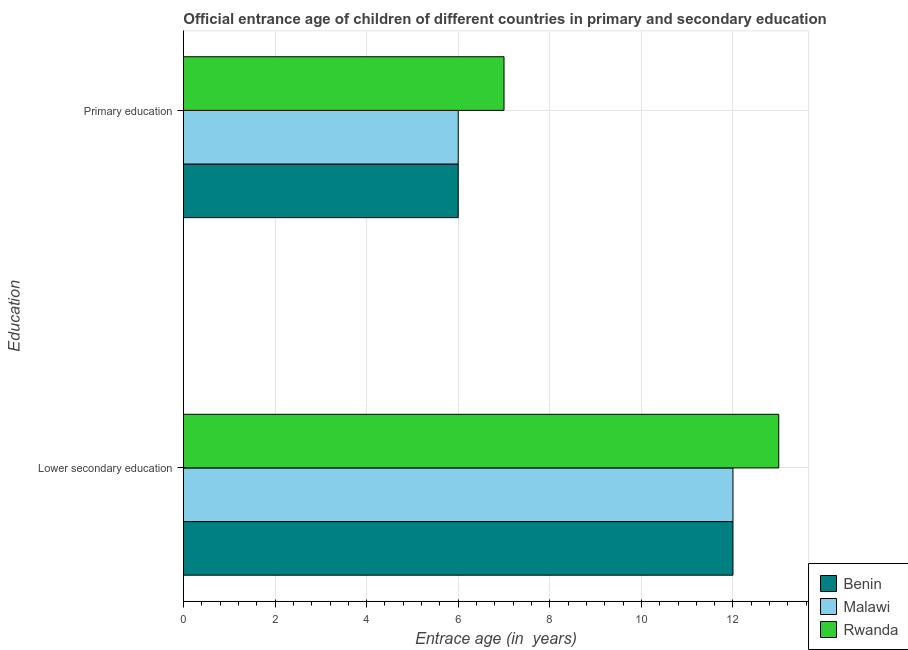How many different coloured bars are there?
Your answer should be compact. 3. How many groups of bars are there?
Your answer should be very brief. 2. Are the number of bars on each tick of the Y-axis equal?
Provide a succinct answer. Yes. What is the label of the 2nd group of bars from the top?
Provide a succinct answer. Lower secondary education. Across all countries, what is the maximum entrance age of children in lower secondary education?
Provide a short and direct response. 13. Across all countries, what is the minimum entrance age of children in lower secondary education?
Keep it short and to the point. 12. In which country was the entrance age of children in lower secondary education maximum?
Provide a succinct answer. Rwanda. In which country was the entrance age of chiildren in primary education minimum?
Ensure brevity in your answer.  Benin. What is the total entrance age of chiildren in primary education in the graph?
Provide a succinct answer. 19. What is the difference between the entrance age of children in lower secondary education in Rwanda and that in Benin?
Provide a short and direct response. 1. What is the difference between the entrance age of chiildren in primary education in Malawi and the entrance age of children in lower secondary education in Benin?
Provide a short and direct response. -6. What is the average entrance age of chiildren in primary education per country?
Offer a very short reply. 6.33. In how many countries, is the entrance age of chiildren in primary education greater than 4.8 years?
Keep it short and to the point. 3. What is the ratio of the entrance age of chiildren in primary education in Malawi to that in Rwanda?
Make the answer very short. 0.86. What does the 3rd bar from the top in Primary education represents?
Offer a terse response. Benin. What does the 2nd bar from the bottom in Primary education represents?
Your answer should be compact. Malawi. Are all the bars in the graph horizontal?
Your answer should be compact. Yes. How many countries are there in the graph?
Give a very brief answer. 3. Does the graph contain any zero values?
Ensure brevity in your answer.  No. How many legend labels are there?
Provide a succinct answer. 3. How are the legend labels stacked?
Provide a short and direct response. Vertical. What is the title of the graph?
Ensure brevity in your answer.  Official entrance age of children of different countries in primary and secondary education. Does "Brazil" appear as one of the legend labels in the graph?
Your answer should be very brief. No. What is the label or title of the X-axis?
Provide a succinct answer. Entrace age (in  years). What is the label or title of the Y-axis?
Make the answer very short. Education. What is the Entrace age (in  years) in Rwanda in Lower secondary education?
Give a very brief answer. 13. What is the Entrace age (in  years) of Benin in Primary education?
Your answer should be very brief. 6. What is the Entrace age (in  years) in Rwanda in Primary education?
Your response must be concise. 7. Across all Education, what is the maximum Entrace age (in  years) in Rwanda?
Offer a very short reply. 13. Across all Education, what is the minimum Entrace age (in  years) in Malawi?
Offer a terse response. 6. What is the total Entrace age (in  years) of Benin in the graph?
Give a very brief answer. 18. What is the difference between the Entrace age (in  years) in Rwanda in Lower secondary education and that in Primary education?
Make the answer very short. 6. What is the average Entrace age (in  years) in Malawi per Education?
Your answer should be compact. 9. What is the ratio of the Entrace age (in  years) in Malawi in Lower secondary education to that in Primary education?
Give a very brief answer. 2. What is the ratio of the Entrace age (in  years) in Rwanda in Lower secondary education to that in Primary education?
Ensure brevity in your answer.  1.86. What is the difference between the highest and the second highest Entrace age (in  years) of Malawi?
Provide a succinct answer. 6. What is the difference between the highest and the lowest Entrace age (in  years) of Benin?
Your response must be concise. 6. What is the difference between the highest and the lowest Entrace age (in  years) of Malawi?
Your answer should be compact. 6. What is the difference between the highest and the lowest Entrace age (in  years) in Rwanda?
Your response must be concise. 6. 